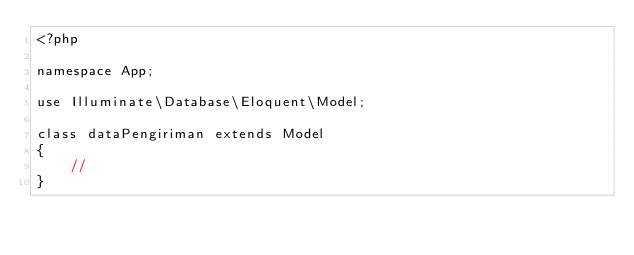Convert code to text. <code><loc_0><loc_0><loc_500><loc_500><_PHP_><?php

namespace App;

use Illuminate\Database\Eloquent\Model;

class dataPengiriman extends Model
{
    //
}
</code> 